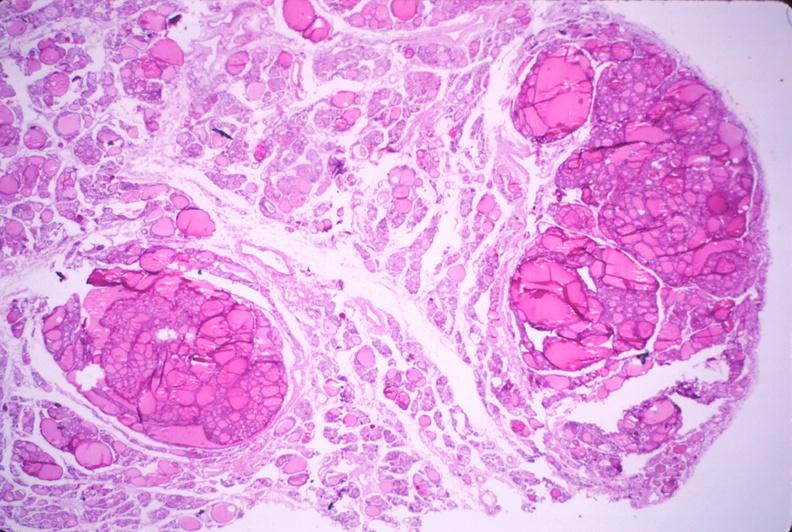where is this part in the figure?
Answer the question using a single word or phrase. Endocrine system 